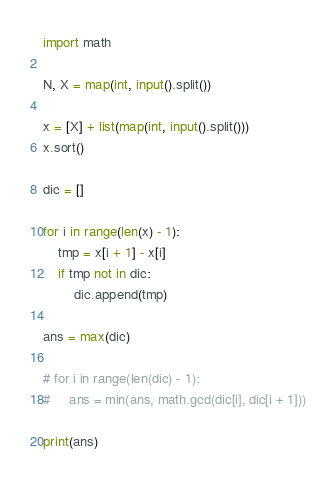<code> <loc_0><loc_0><loc_500><loc_500><_Python_>import math

N, X = map(int, input().split())

x = [X] + list(map(int, input().split()))
x.sort()

dic = []

for i in range(len(x) - 1):
    tmp = x[i + 1] - x[i]
    if tmp not in dic:
        dic.append(tmp)

ans = max(dic)

# for i in range(len(dic) - 1):
#     ans = min(ans, math.gcd(dic[i], dic[i + 1]))

print(ans)</code> 